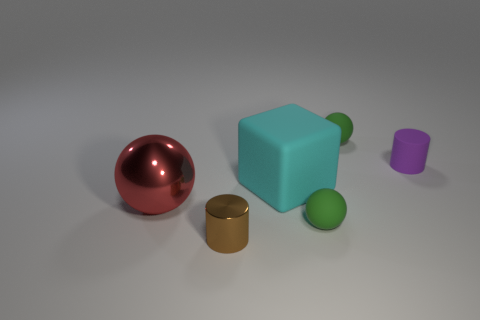Is the number of red shiny things greater than the number of small brown shiny spheres?
Keep it short and to the point. Yes. How big is the thing that is behind the cyan rubber cube and to the left of the purple rubber object?
Make the answer very short. Small. Is the green object that is in front of the matte cube made of the same material as the cylinder on the left side of the small purple rubber thing?
Offer a terse response. No. There is a purple thing that is the same size as the brown object; what is its shape?
Ensure brevity in your answer.  Cylinder. Is the number of small objects less than the number of tiny brown cylinders?
Make the answer very short. No. Are there any green things behind the thing that is behind the purple cylinder?
Ensure brevity in your answer.  No. There is a big thing behind the metal thing that is on the left side of the brown cylinder; are there any cylinders that are on the right side of it?
Provide a succinct answer. Yes. There is a big thing that is left of the small brown cylinder; is it the same shape as the large object on the right side of the small brown thing?
Give a very brief answer. No. There is another object that is the same material as the red object; what color is it?
Give a very brief answer. Brown. Is the number of big shiny things that are behind the red shiny sphere less than the number of big red balls?
Your answer should be very brief. Yes. 